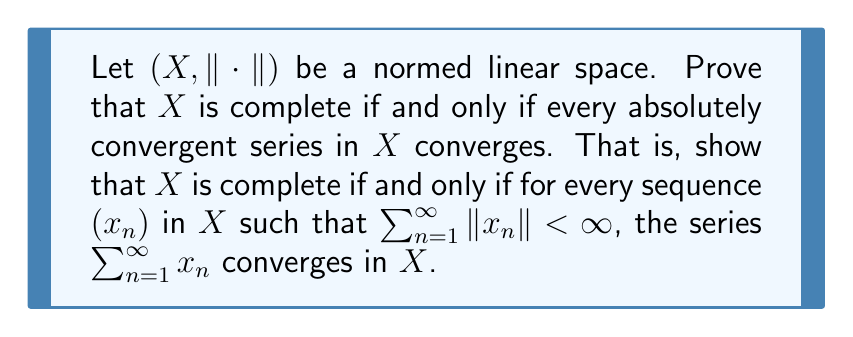Give your solution to this math problem. To prove this statement, we'll show both directions of the if and only if condition.

1. First, let's prove that if $X$ is complete, then every absolutely convergent series in $X$ converges.

Assume $X$ is complete and let $(x_n)$ be a sequence in $X$ such that $\sum_{n=1}^{\infty} \|x_n\| < \infty$.

Let $s_k = \sum_{n=1}^k x_n$ be the partial sums of the series.

For any $m > k$, we have:

$$\|s_m - s_k\| = \left\|\sum_{n=k+1}^m x_n\right\| \leq \sum_{n=k+1}^m \|x_n\|$$

As $\sum_{n=1}^{\infty} \|x_n\| < \infty$, for any $\epsilon > 0$, there exists $N$ such that for all $m > k \geq N$:

$$\sum_{n=k+1}^m \|x_n\| < \epsilon$$

This means $(s_k)$ is a Cauchy sequence in $X$. Since $X$ is complete, $(s_k)$ converges to some $s \in X$. Therefore, $\sum_{n=1}^{\infty} x_n$ converges to $s$.

2. Now, let's prove that if every absolutely convergent series in $X$ converges, then $X$ is complete.

Assume every absolutely convergent series in $X$ converges, and let $(y_n)$ be a Cauchy sequence in $X$.

We need to construct an absolutely convergent series from this Cauchy sequence.

Choose a subsequence $(y_{n_k})$ of $(y_n)$ such that for all $k$:

$$\|y_{n_{k+1}} - y_{n_k}\| < \frac{1}{2^k}$$

Define $x_1 = y_{n_1}$ and $x_k = y_{n_k} - y_{n_{k-1}}$ for $k \geq 2$.

Then $\sum_{k=1}^{\infty} \|x_k\| < \|y_{n_1}\| + \sum_{k=2}^{\infty} \frac{1}{2^{k-1}} < \infty$

By our assumption, $\sum_{k=1}^{\infty} x_k$ converges to some $y \in X$.

Observe that $\sum_{k=1}^m x_k = y_{n_m}$ for all $m$.

Therefore, $y_{n_m} \to y$ as $m \to \infty$.

Since $(y_{n_k})$ is a subsequence of $(y_n)$ and $(y_n)$ is Cauchy, we can conclude that $y_n \to y$ as $n \to \infty$.

Thus, every Cauchy sequence in $X$ converges, so $X$ is complete.
Answer: A normed linear space $(X, \|\cdot\|)$ is complete if and only if every absolutely convergent series in $X$ converges. 